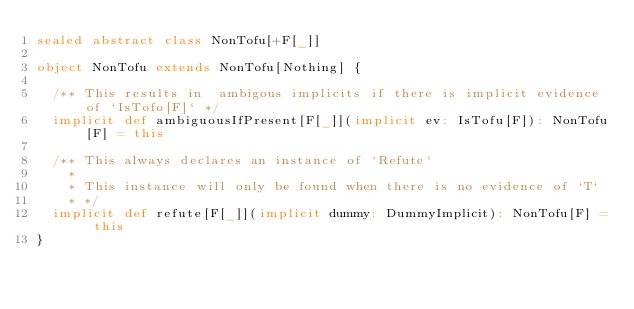Convert code to text. <code><loc_0><loc_0><loc_500><loc_500><_Scala_>sealed abstract class NonTofu[+F[_]]

object NonTofu extends NonTofu[Nothing] {

  /** This results in  ambigous implicits if there is implicit evidence of `IsTofo[F]` */
  implicit def ambiguousIfPresent[F[_]](implicit ev: IsTofu[F]): NonTofu[F] = this

  /** This always declares an instance of `Refute`
    *
    * This instance will only be found when there is no evidence of `T`
    * */
  implicit def refute[F[_]](implicit dummy: DummyImplicit): NonTofu[F] = this
}
</code> 